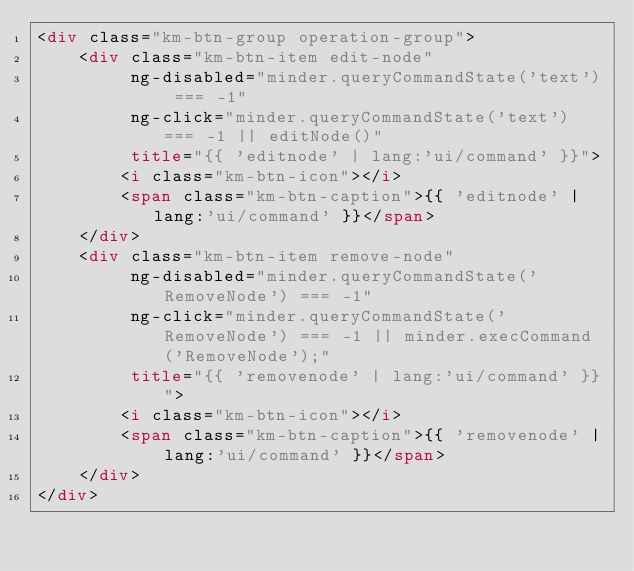Convert code to text. <code><loc_0><loc_0><loc_500><loc_500><_HTML_><div class="km-btn-group operation-group">
    <div class="km-btn-item edit-node"
         ng-disabled="minder.queryCommandState('text') === -1"
         ng-click="minder.queryCommandState('text') === -1 || editNode()"
         title="{{ 'editnode' | lang:'ui/command' }}">
        <i class="km-btn-icon"></i>
        <span class="km-btn-caption">{{ 'editnode' | lang:'ui/command' }}</span>
    </div>
    <div class="km-btn-item remove-node"
         ng-disabled="minder.queryCommandState('RemoveNode') === -1"
         ng-click="minder.queryCommandState('RemoveNode') === -1 || minder.execCommand('RemoveNode');"
         title="{{ 'removenode' | lang:'ui/command' }}">
        <i class="km-btn-icon"></i>
        <span class="km-btn-caption">{{ 'removenode' | lang:'ui/command' }}</span>
    </div>
</div>
</code> 